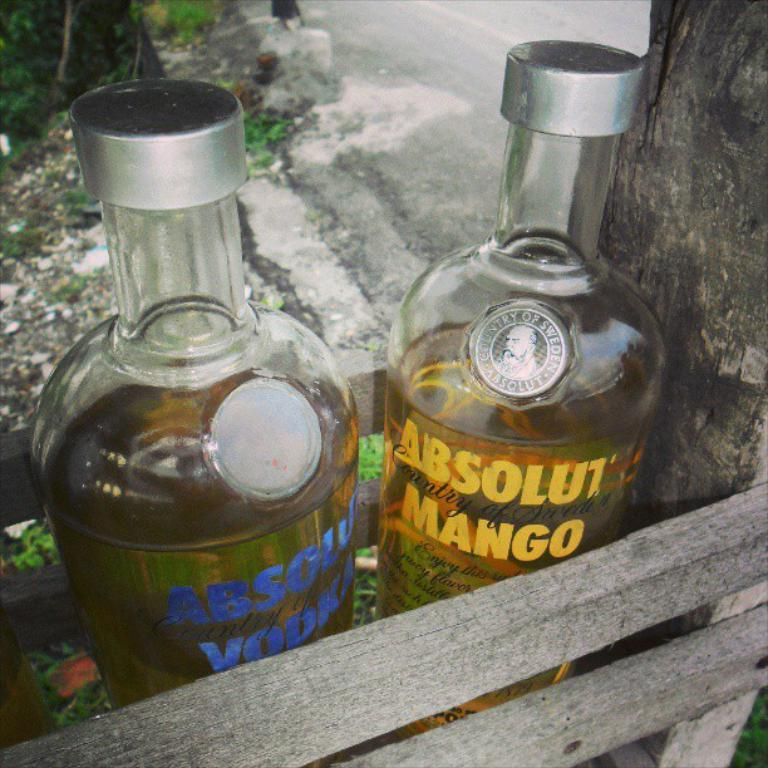<image>
Offer a succinct explanation of the picture presented. One of the two Absolut Vodka bottles in a wooden crate is flavored with mango. 